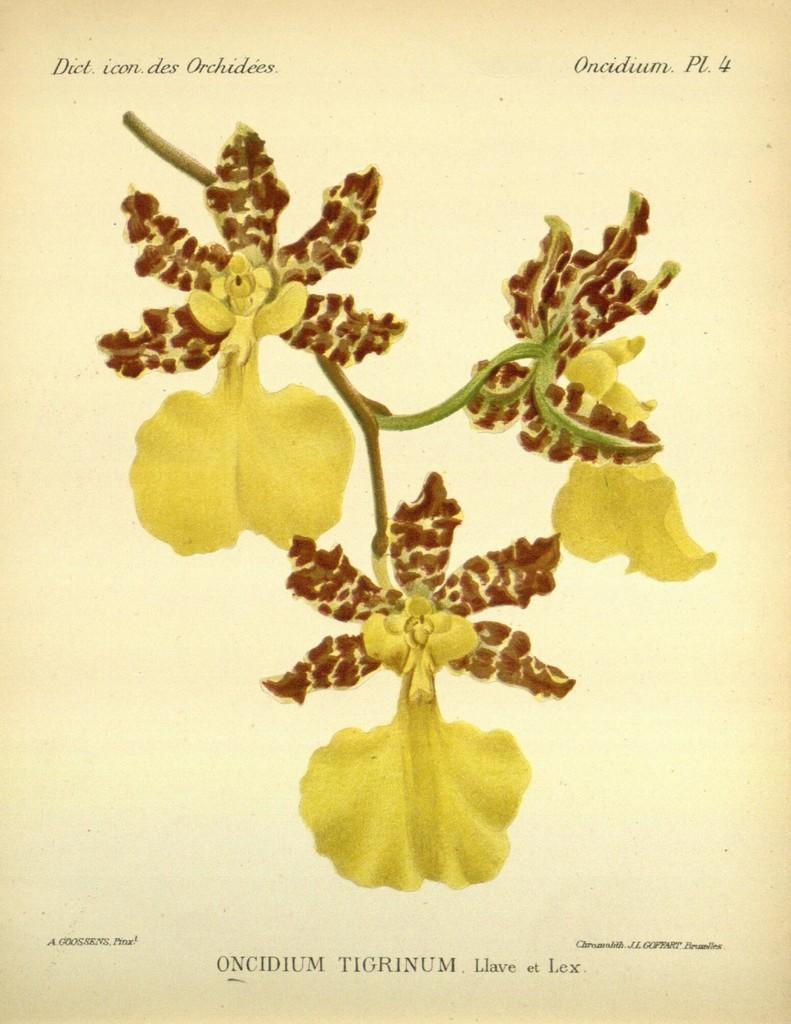<image>
Give a short and clear explanation of the subsequent image. A drawing of a plant with the label Oncidium Tigrinum. 